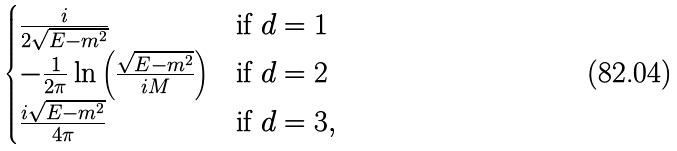<formula> <loc_0><loc_0><loc_500><loc_500>\begin{cases} \frac { i } { 2 \sqrt { E - m ^ { 2 } } } & \text {if $d=1$} \\ - \frac { 1 } { 2 \pi } \ln \left ( \frac { \sqrt { E - m ^ { 2 } } } { i M } \right ) & \text {if $d=2$} \\ \frac { i \sqrt { E - m ^ { 2 } } } { 4 \pi } & \text {if $d=3$} , \end{cases}</formula> 